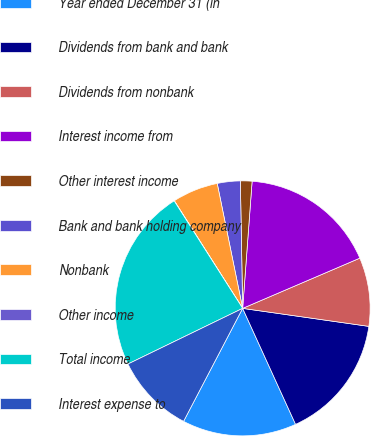Convert chart. <chart><loc_0><loc_0><loc_500><loc_500><pie_chart><fcel>Year ended December 31 (in<fcel>Dividends from bank and bank<fcel>Dividends from nonbank<fcel>Interest income from<fcel>Other interest income<fcel>Bank and bank holding company<fcel>Nonbank<fcel>Other income<fcel>Total income<fcel>Interest expense to<nl><fcel>14.48%<fcel>15.93%<fcel>8.7%<fcel>17.37%<fcel>1.47%<fcel>2.91%<fcel>5.81%<fcel>0.02%<fcel>23.16%<fcel>10.14%<nl></chart> 